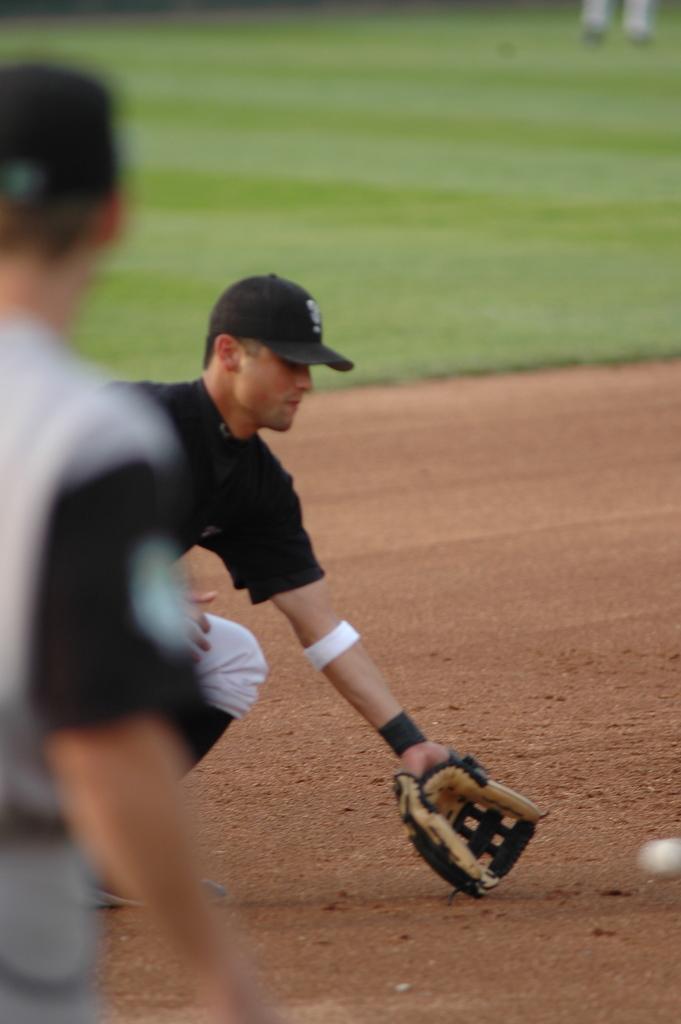How many people are visible on the left side of the image? There are two persons visible on the left side of the image. What is the man holding in the image? The man is holding a glove in the image. What object is visible on the right side of the image? There is a ball visible on the right side of the image. What type of surface is present at the top of the image? Grass is present at the top of the image. What type of knot is being tied by the police officer in the image? There is no police officer or knot present in the image. What boundary is visible in the image? There is no boundary visible in the image. 